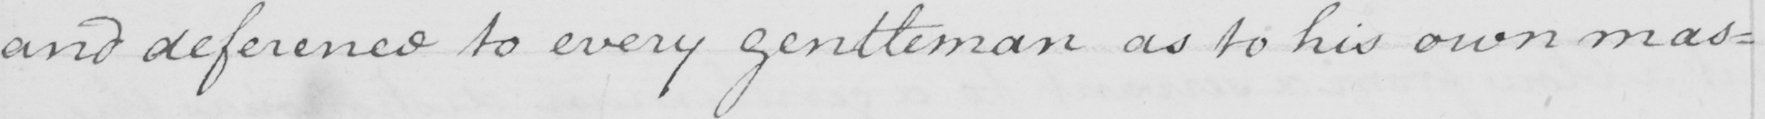Can you tell me what this handwritten text says? and deference to every gentleman as to his own mas= 